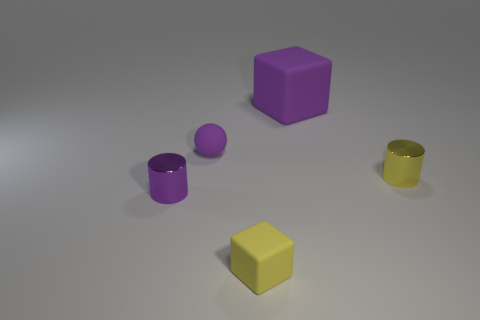Which objects in the image appear to have smooth surfaces? All the objects in the image exhibit smooth surfaces, which reflects the light and gives them a slight sheen. The precise rendering of the materials emphasizes their smooth texture. 